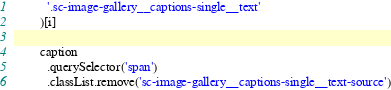Convert code to text. <code><loc_0><loc_0><loc_500><loc_500><_JavaScript_>          '.sc-image-gallery__captions-single__text'
        )[i]

        caption
          .querySelector('span')
          .classList.remove('sc-image-gallery__captions-single__text-source')
</code> 